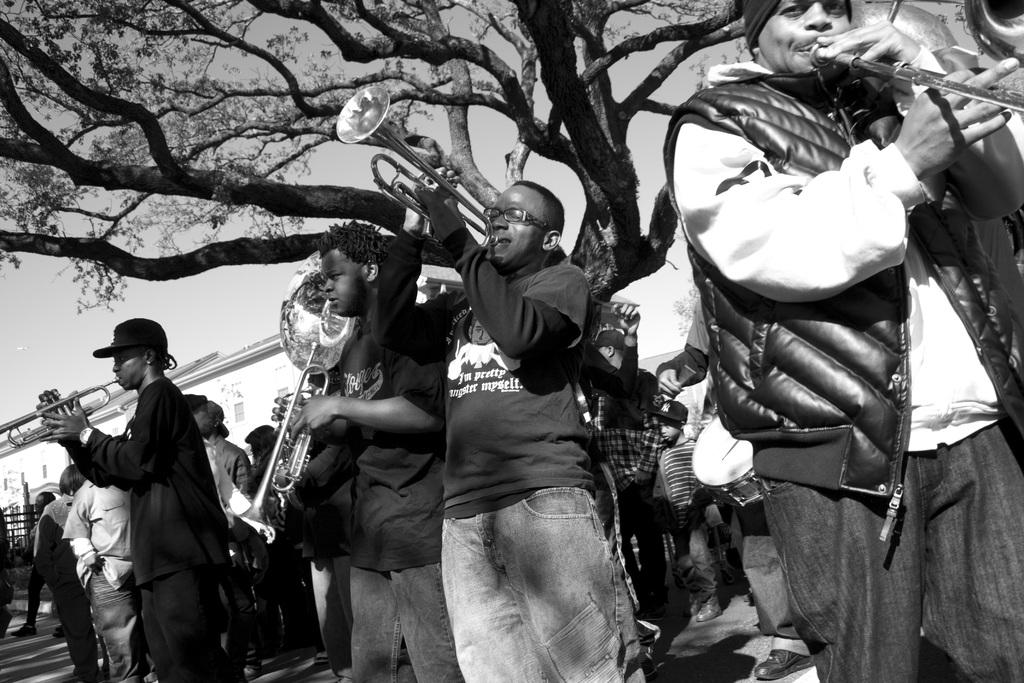What are the people in the image doing? The people in the image are playing musical instruments. Can you describe the background of the image? There is a tree in the background of the image. What is the afterthought of the meeting in the image? There is no meeting present in the image, so there cannot be an afterthought. What is the common interest of the people in the image? We cannot determine the common interest of the people in the image based on the provided facts. 